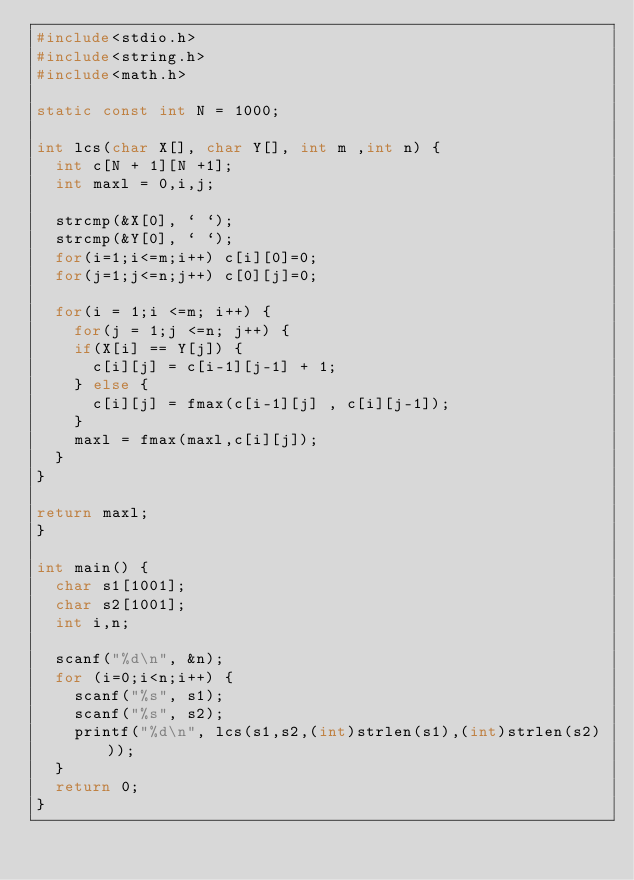Convert code to text. <code><loc_0><loc_0><loc_500><loc_500><_C_>#include<stdio.h>
#include<string.h>
#include<math.h>

static const int N = 1000;

int lcs(char X[], char Y[], int m ,int n) {
  int c[N + 1][N +1];
  int maxl = 0,i,j;

  strcmp(&X[0], ` `);
  strcmp(&Y[0], ` `);
  for(i=1;i<=m;i++) c[i][0]=0;
  for(j=1;j<=n;j++) c[0][j]=0;

  for(i = 1;i <=m; i++) {
    for(j = 1;j <=n; j++) {
    if(X[i] == Y[j]) {
      c[i][j] = c[i-1][j-1] + 1;
    } else {
      c[i][j] = fmax(c[i-1][j] , c[i][j-1]);
    }
    maxl = fmax(maxl,c[i][j]);
  }
}

return maxl;
}

int main() {
  char s1[1001];
  char s2[1001];
  int i,n;

  scanf("%d\n", &n);
  for (i=0;i<n;i++) {
    scanf("%s", s1);
    scanf("%s", s2);
    printf("%d\n", lcs(s1,s2,(int)strlen(s1),(int)strlen(s2)));
  }
  return 0;
}</code> 